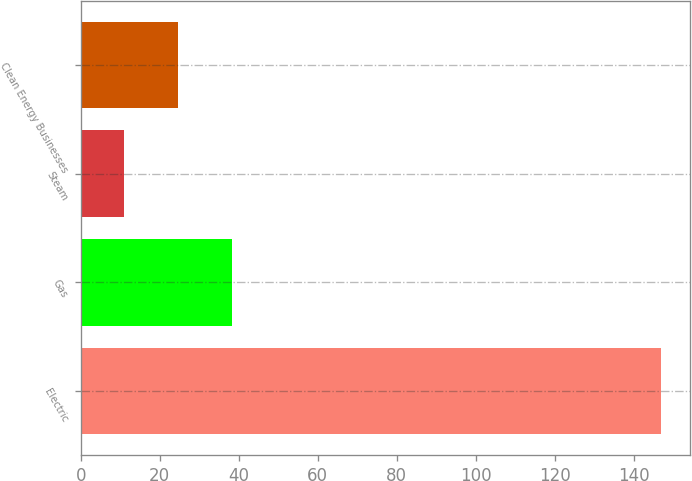<chart> <loc_0><loc_0><loc_500><loc_500><bar_chart><fcel>Electric<fcel>Gas<fcel>Steam<fcel>Clean Energy Businesses<nl><fcel>147<fcel>38.2<fcel>11<fcel>24.6<nl></chart> 